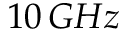<formula> <loc_0><loc_0><loc_500><loc_500>1 0 \, G H z</formula> 